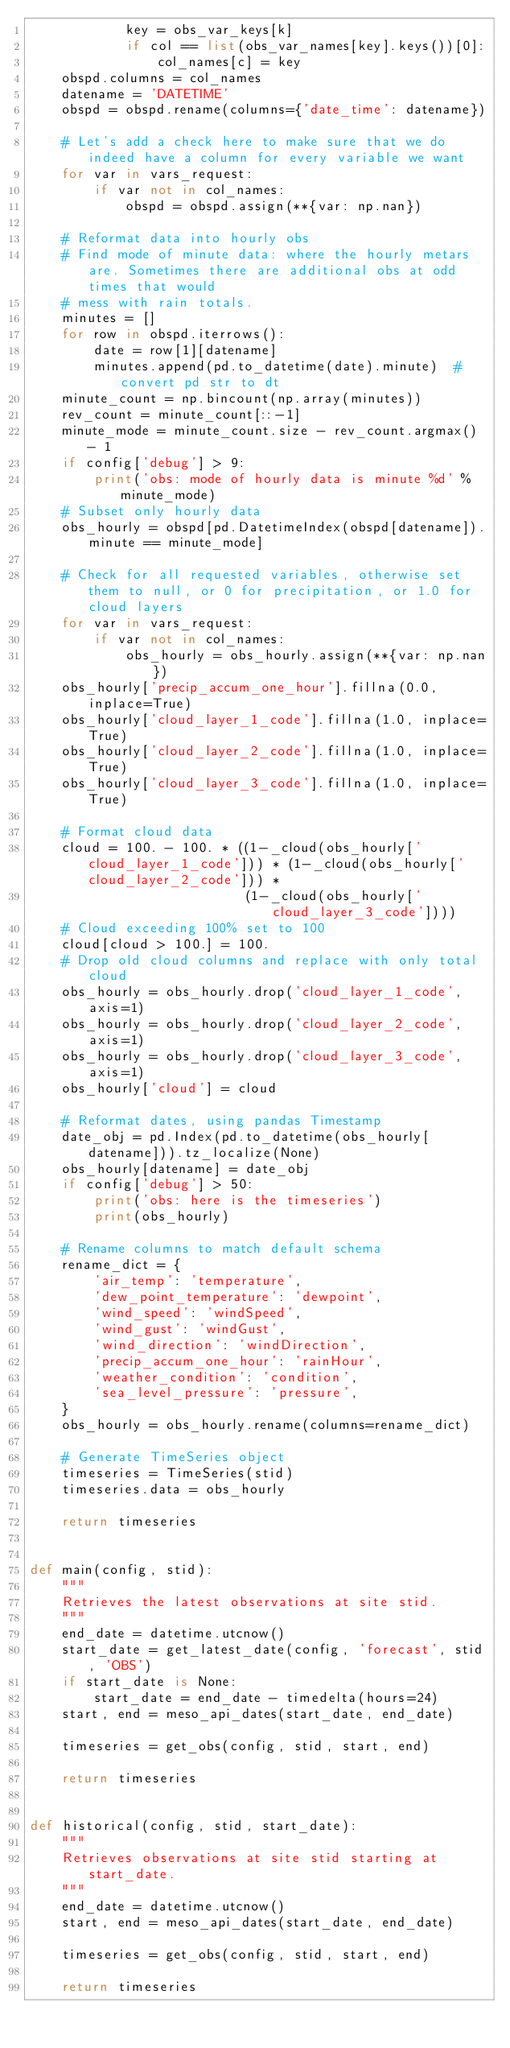<code> <loc_0><loc_0><loc_500><loc_500><_Python_>            key = obs_var_keys[k]
            if col == list(obs_var_names[key].keys())[0]:
                col_names[c] = key
    obspd.columns = col_names
    datename = 'DATETIME'
    obspd = obspd.rename(columns={'date_time': datename})

    # Let's add a check here to make sure that we do indeed have a column for every variable we want
    for var in vars_request:
        if var not in col_names:
            obspd = obspd.assign(**{var: np.nan})

    # Reformat data into hourly obs
    # Find mode of minute data: where the hourly metars are. Sometimes there are additional obs at odd times that would
    # mess with rain totals.
    minutes = []
    for row in obspd.iterrows():
        date = row[1][datename]
        minutes.append(pd.to_datetime(date).minute)  # convert pd str to dt
    minute_count = np.bincount(np.array(minutes))
    rev_count = minute_count[::-1]
    minute_mode = minute_count.size - rev_count.argmax() - 1
    if config['debug'] > 9:
        print('obs: mode of hourly data is minute %d' % minute_mode)
    # Subset only hourly data
    obs_hourly = obspd[pd.DatetimeIndex(obspd[datename]).minute == minute_mode]

    # Check for all requested variables, otherwise set them to null, or 0 for precipitation, or 1.0 for cloud layers
    for var in vars_request:
        if var not in col_names:
            obs_hourly = obs_hourly.assign(**{var: np.nan})
    obs_hourly['precip_accum_one_hour'].fillna(0.0, inplace=True)
    obs_hourly['cloud_layer_1_code'].fillna(1.0, inplace=True)
    obs_hourly['cloud_layer_2_code'].fillna(1.0, inplace=True)
    obs_hourly['cloud_layer_3_code'].fillna(1.0, inplace=True)

    # Format cloud data
    cloud = 100. - 100. * ((1-_cloud(obs_hourly['cloud_layer_1_code'])) * (1-_cloud(obs_hourly['cloud_layer_2_code'])) *
                           (1-_cloud(obs_hourly['cloud_layer_3_code'])))
    # Cloud exceeding 100% set to 100
    cloud[cloud > 100.] = 100.
    # Drop old cloud columns and replace with only total cloud
    obs_hourly = obs_hourly.drop('cloud_layer_1_code', axis=1)
    obs_hourly = obs_hourly.drop('cloud_layer_2_code', axis=1)
    obs_hourly = obs_hourly.drop('cloud_layer_3_code', axis=1)
    obs_hourly['cloud'] = cloud

    # Reformat dates, using pandas Timestamp
    date_obj = pd.Index(pd.to_datetime(obs_hourly[datename])).tz_localize(None)
    obs_hourly[datename] = date_obj
    if config['debug'] > 50:
        print('obs: here is the timeseries')
        print(obs_hourly)

    # Rename columns to match default schema
    rename_dict = {
        'air_temp': 'temperature',
        'dew_point_temperature': 'dewpoint',
        'wind_speed': 'windSpeed',
        'wind_gust': 'windGust',
        'wind_direction': 'windDirection',
        'precip_accum_one_hour': 'rainHour',
        'weather_condition': 'condition',
        'sea_level_pressure': 'pressure',
    }
    obs_hourly = obs_hourly.rename(columns=rename_dict)

    # Generate TimeSeries object
    timeseries = TimeSeries(stid)
    timeseries.data = obs_hourly

    return timeseries


def main(config, stid):
    """
    Retrieves the latest observations at site stid.
    """
    end_date = datetime.utcnow()
    start_date = get_latest_date(config, 'forecast', stid, 'OBS')
    if start_date is None:
        start_date = end_date - timedelta(hours=24)
    start, end = meso_api_dates(start_date, end_date)

    timeseries = get_obs(config, stid, start, end)

    return timeseries


def historical(config, stid, start_date):
    """
    Retrieves observations at site stid starting at start_date.
    """
    end_date = datetime.utcnow()
    start, end = meso_api_dates(start_date, end_date)

    timeseries = get_obs(config, stid, start, end)

    return timeseries
</code> 